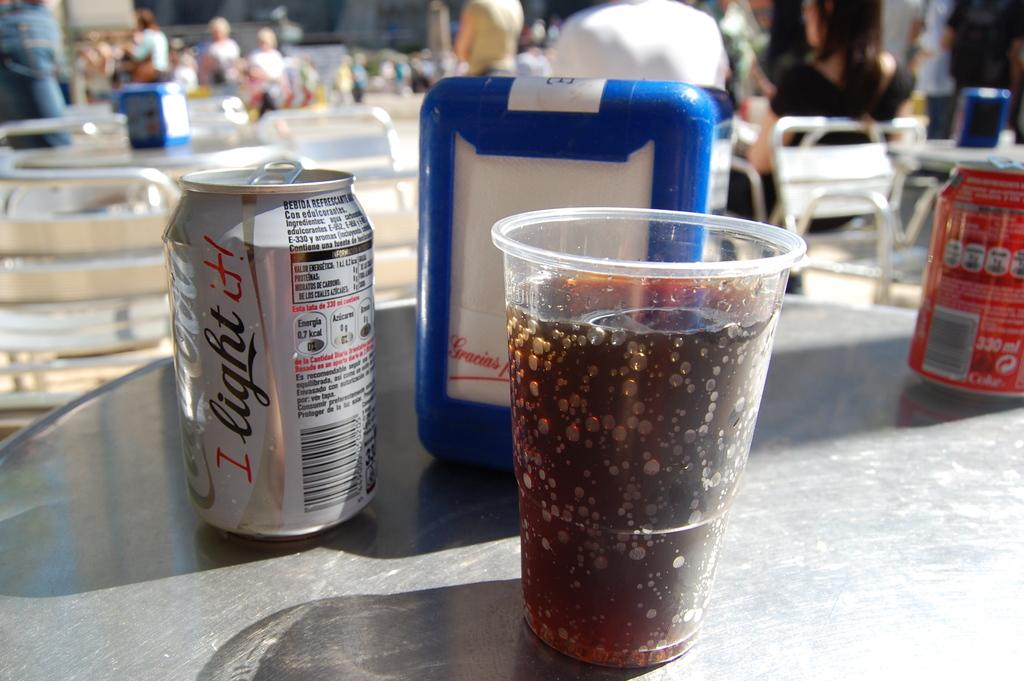<image>
Provide a brief description of the given image. A cup of Coca-Cola light is on a table with napkins and a soda can. 